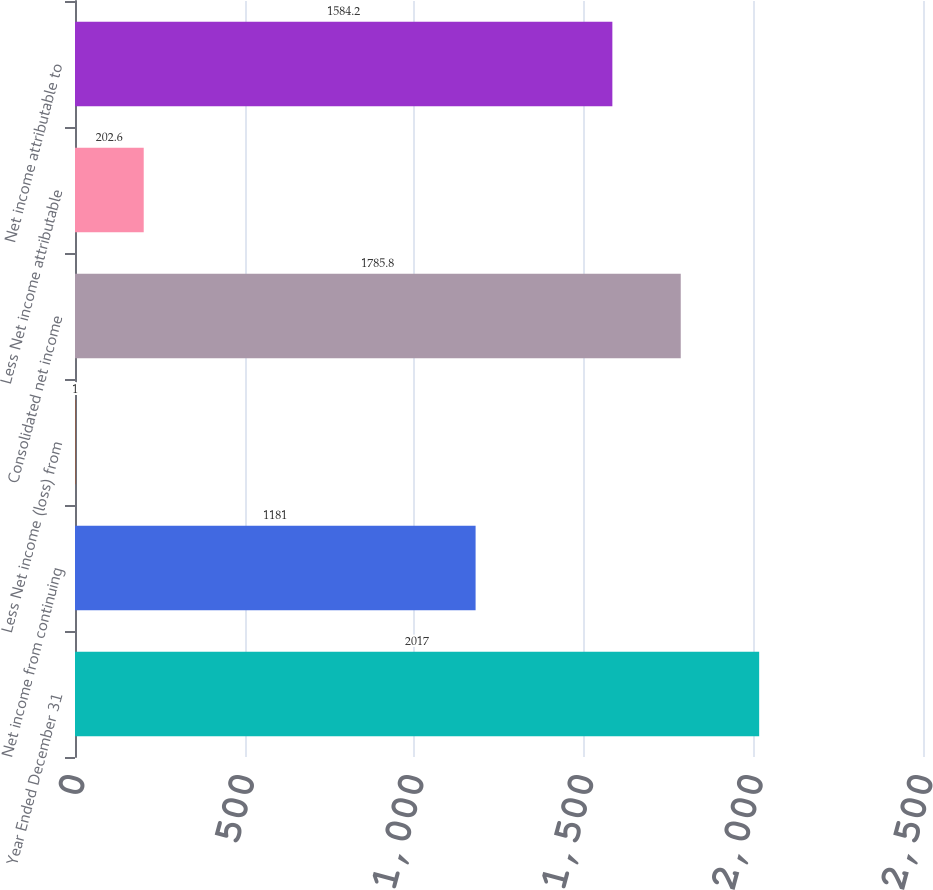<chart> <loc_0><loc_0><loc_500><loc_500><bar_chart><fcel>Year Ended December 31<fcel>Net income from continuing<fcel>Less Net income (loss) from<fcel>Consolidated net income<fcel>Less Net income attributable<fcel>Net income attributable to<nl><fcel>2017<fcel>1181<fcel>1<fcel>1785.8<fcel>202.6<fcel>1584.2<nl></chart> 